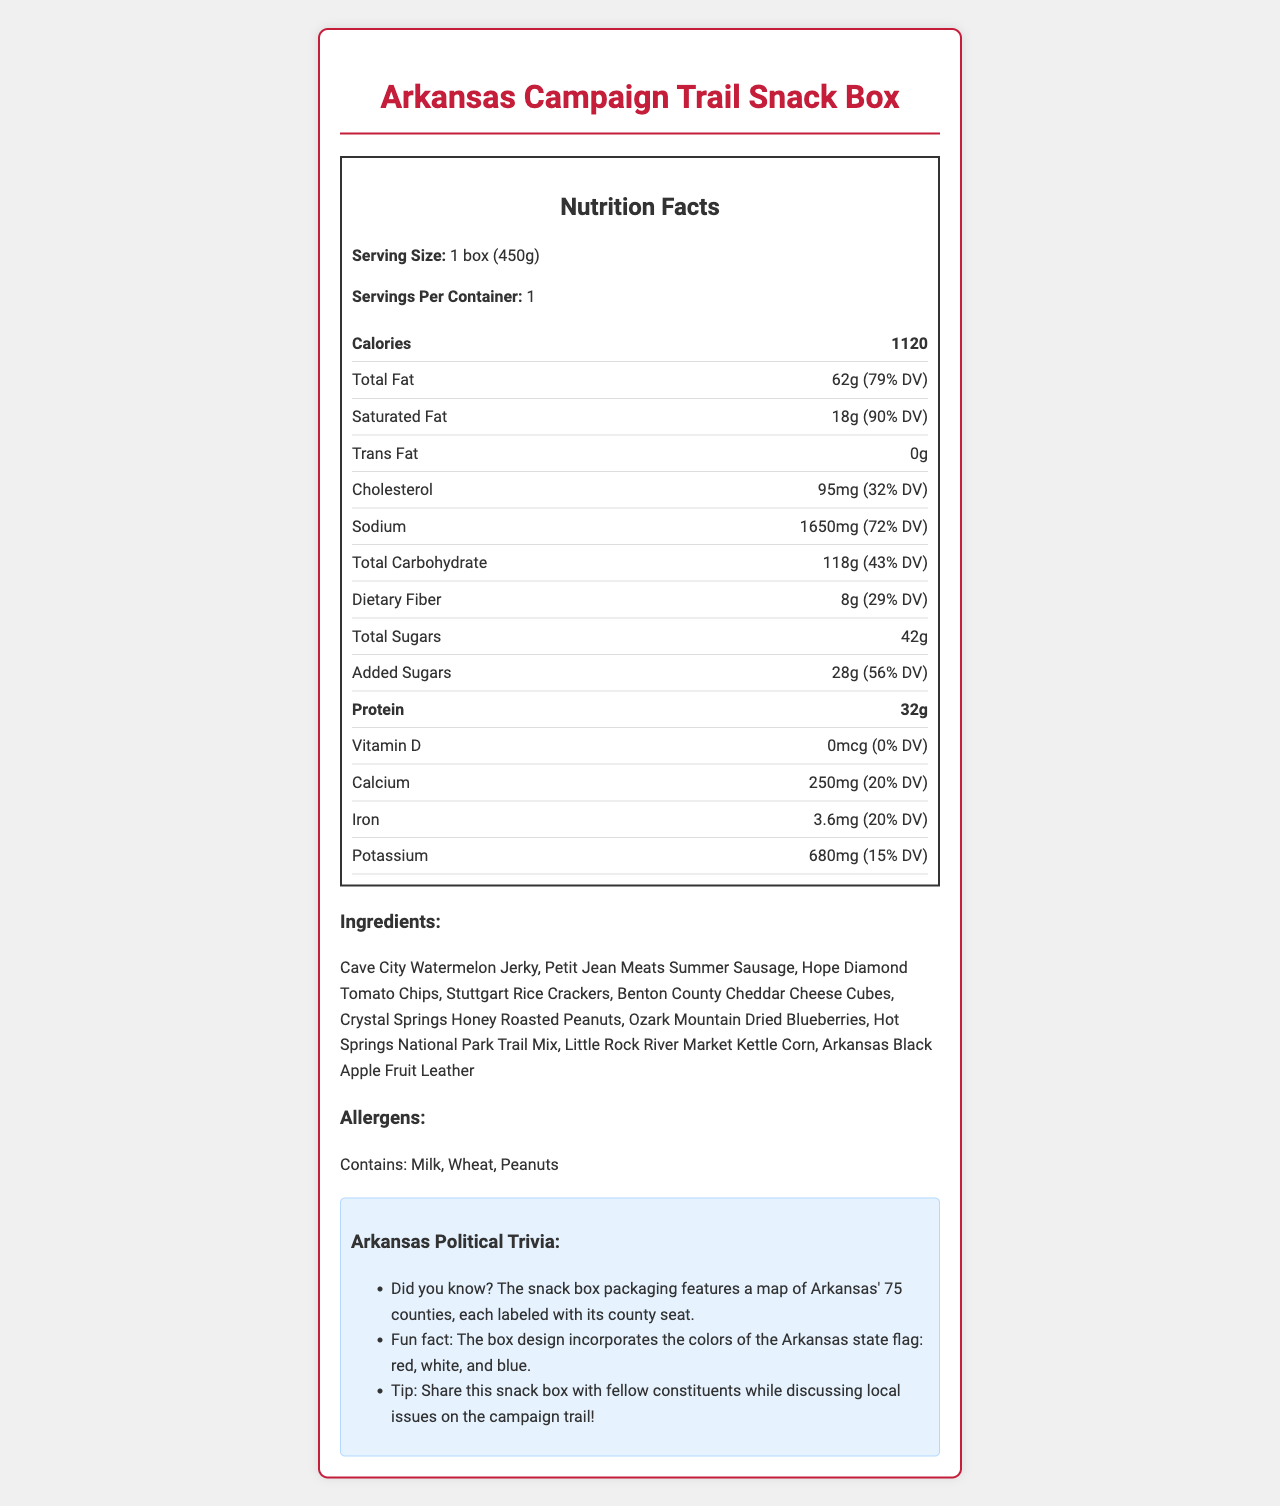what is the serving size of the Arkansas Campaign Trail Snack Box? The serving size is listed as "1 box (450g)" in the document.
Answer: 1 box (450g) how many calories are in one serving of the snack box? The calorie count is specified as 1120 calories per serving.
Answer: 1120 which ingredient provides a high amount of total fat? The document provides the total fat content but does not attribute it to any specific ingredient.
Answer: Cannot be determined does the snack box contain any trans fat? The document shows the trans fat amount as 0 grams.
Answer: No what are the top three ingredients of the snack box? The ingredients are listed as: Cave City Watermelon Jerky, Petit Jean Meats Summer Sausage, Hope Diamond Tomato Chips, Stuttgart Rice Crackers, Benton County Cheddar Cheese Cubes, Crystal Springs Honey Roasted Peanuts, Ozark Mountain Dried Blueberries, Hot Springs National Park Trail Mix, Little Rock River Market Kettle Corn, Arkansas Black Apple Fruit Leather.
Answer: Cave City Watermelon Jerky, Petit Jean Meats Summer Sausage, Hope Diamond Tomato Chips how much sodium does one box contain? The sodium content is stated as 1650 mg per serving.
Answer: 1650 mg how much dietary fiber is there in the snack box, and what percentage of the daily value does it represent? The dietary fiber content is 8 grams, which represents 29% of the daily value.
Answer: 8g, 29% DV which vitamin and mineral are most abundant in the snack box in terms of daily value percentage? Saturated Fat contributes 90% of the daily value, which is the highest percentage among the listed nutrients.
Answer: Saturated Fat, 90% DV what allergens are included in the snack box? The allergen section specifies that the box contains Milk, Wheat, and Peanuts.
Answer: Milk, Wheat, Peanuts which nutrient contributes 32% of its daily value in the snack box? A. Calcium B. Iron C. Cholesterol Cholesterol contributes 32% of the daily value as per the information on the label.
Answer: C. Cholesterol which nutrient has the highest daily value percentage? A. Sodium B. Saturated Fat C. Added Sugars Saturated Fat has a daily value percentage of 90%, which is higher than Sodium (72%) and Added Sugars (56%).
Answer: B. Saturated Fat is there any additional sugar added to the product? The document lists "Added Sugars" as 28 grams, indicating additional sugar.
Answer: Yes summarize the main idea of this document. The document features the Arkansas Campaign Trail Snack Box's nutritional facts per 450g serving, ingredient list, allergens, and some interesting political trivia relevant to Arkansas.
Answer: The document provides detailed nutritional information and ingredient list for the Arkansas Campaign Trail Snack Box, highlighting various regional foods from Arkansas, along with political trivia and allergen information. which nutrients are not mentioned in the document? The document does not provide information about nutrients that could potentially be present but are unspecified.
Answer: Cannot be determined 